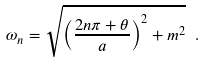<formula> <loc_0><loc_0><loc_500><loc_500>\omega _ { n } = \sqrt { \left ( \frac { 2 n \pi + \theta } { a } \right ) ^ { 2 } + m ^ { 2 } } \ .</formula> 